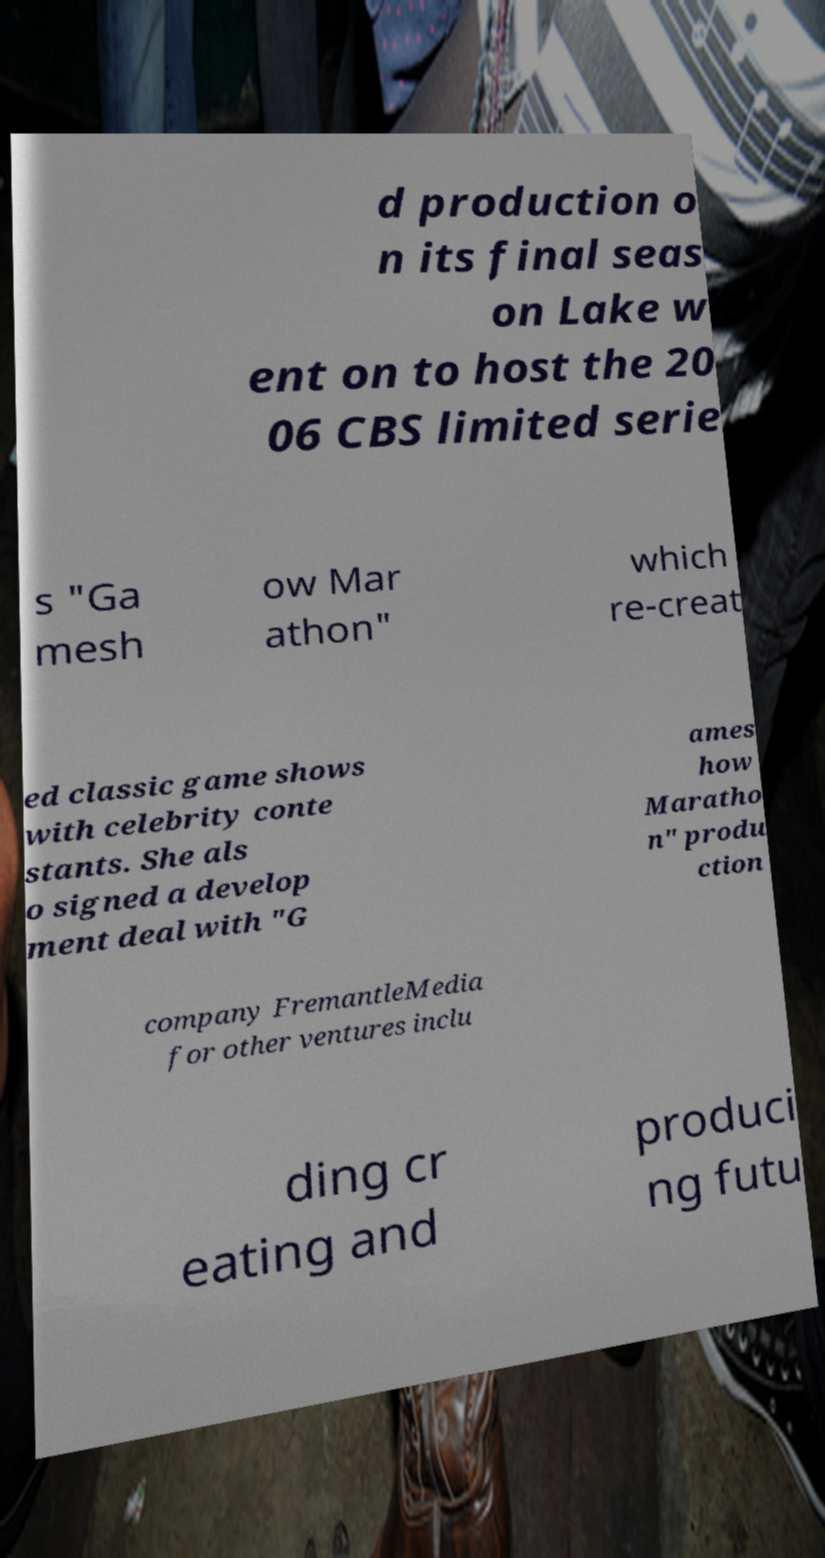Could you extract and type out the text from this image? d production o n its final seas on Lake w ent on to host the 20 06 CBS limited serie s "Ga mesh ow Mar athon" which re-creat ed classic game shows with celebrity conte stants. She als o signed a develop ment deal with "G ames how Maratho n" produ ction company FremantleMedia for other ventures inclu ding cr eating and produci ng futu 